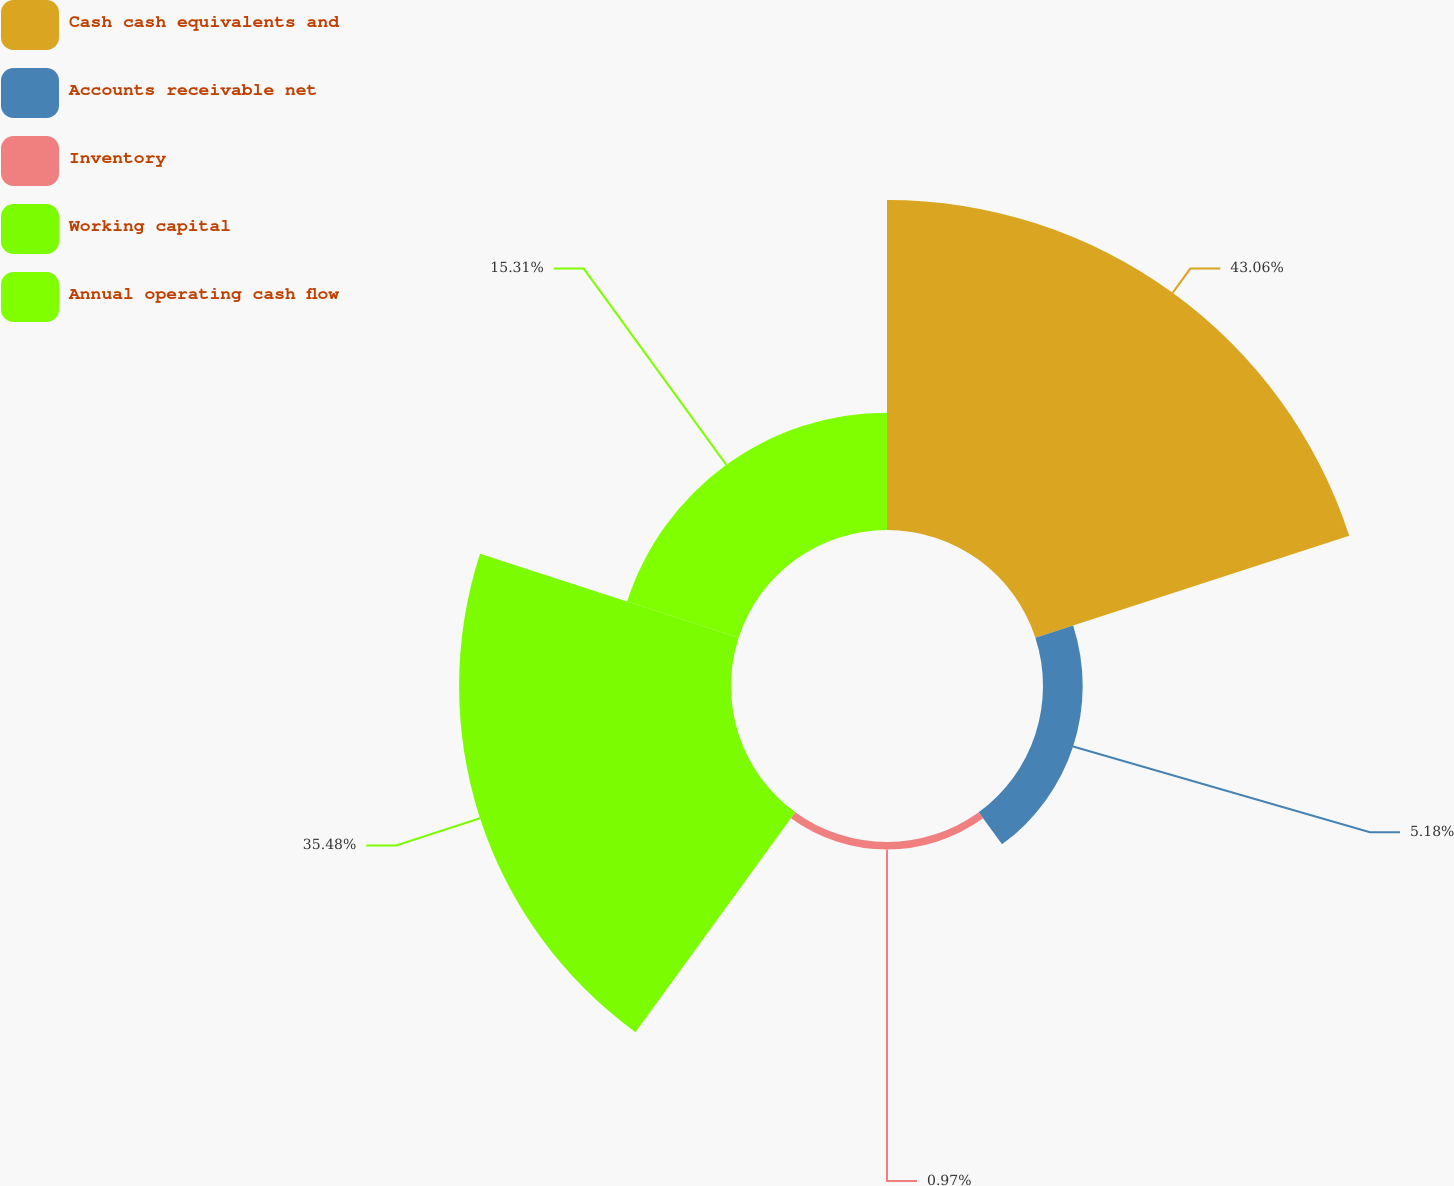Convert chart to OTSL. <chart><loc_0><loc_0><loc_500><loc_500><pie_chart><fcel>Cash cash equivalents and<fcel>Accounts receivable net<fcel>Inventory<fcel>Working capital<fcel>Annual operating cash flow<nl><fcel>43.06%<fcel>5.18%<fcel>0.97%<fcel>35.48%<fcel>15.31%<nl></chart> 